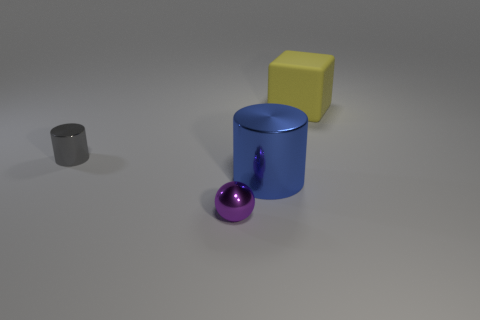What are the different colors of objects present in the image? The image showcases objects in four distinct colors: gray for the small cylinder, blue for the larger cylinder, purple for the sphere, and yellow for the cube. 